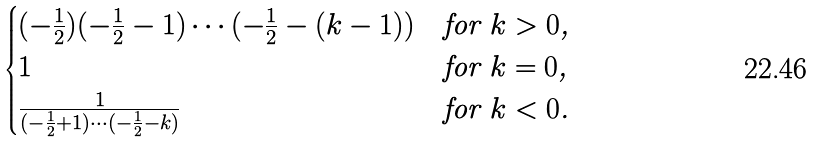<formula> <loc_0><loc_0><loc_500><loc_500>\begin{cases} ( - \frac { 1 } { 2 } ) ( - \frac { 1 } { 2 } - 1 ) \cdots ( - \frac { 1 } { 2 } - ( k - 1 ) ) & \text {for $k>0$,} \\ 1 & \text {for $k=0$,} \\ \frac { 1 } { ( - \frac { 1 } { 2 } + 1 ) \cdots ( - \frac { 1 } { 2 } - k ) } & \text {for $k<0$.} \end{cases}</formula> 